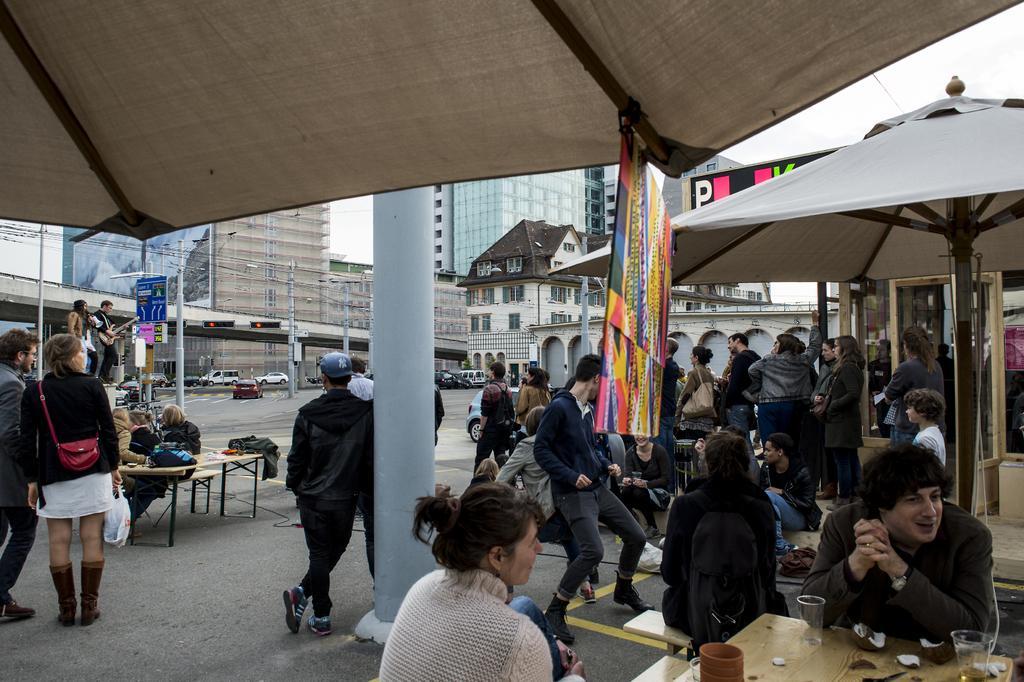In one or two sentences, can you explain what this image depicts? In this image I can see number of persons are standing on the ground, few persons are sitting on chairs, few tents which are white in color, few poles, few boards, few tables and on the table I can see few glasses and few other objects. In the background I can see few buildings, few vehicles and the sky. 